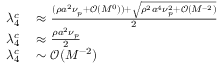Convert formula to latex. <formula><loc_0><loc_0><loc_500><loc_500>\begin{array} { r l } { \lambda _ { 4 } ^ { c } } & \approx \frac { ( \rho a ^ { 2 } \nu _ { p } + \mathcal { O } ( M ^ { 0 } ) ) + \sqrt { \rho ^ { 2 } a ^ { 4 } \nu _ { p } ^ { 2 } + \mathcal { O } ( M ^ { - 2 } ) } } { 2 } } \\ { \lambda _ { 4 } ^ { c } } & \approx \frac { \rho a ^ { 2 } \nu _ { p } } { 2 } } \\ { \lambda _ { 4 } ^ { c } } & \sim \mathcal { O } ( M ^ { - 2 } ) } \end{array}</formula> 